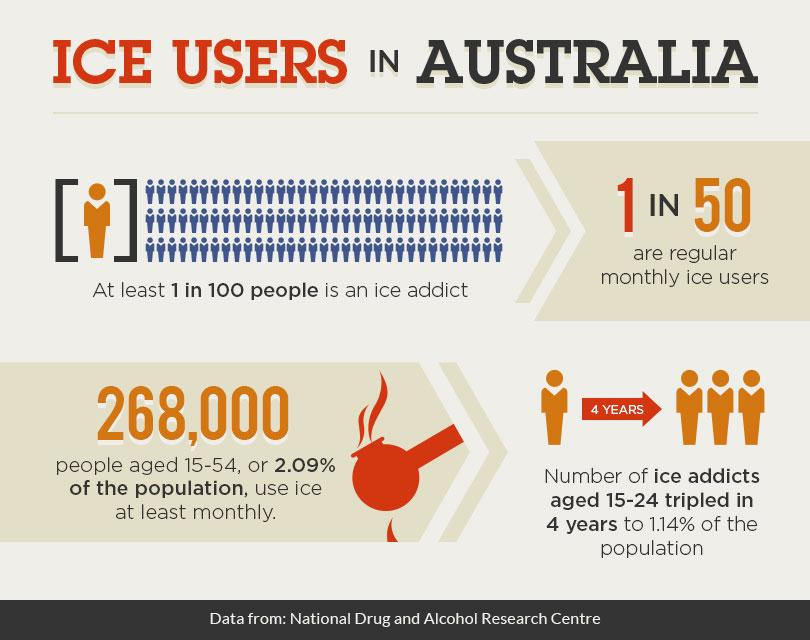List a handful of essential elements in this visual. According to recent statistics, approximately 1 in every 50 individuals use ice on a monthly basis. According to data, approximately 2.09% of the population uses ice monthly. The inscription on the arrow indicates that 4 years have passed. 